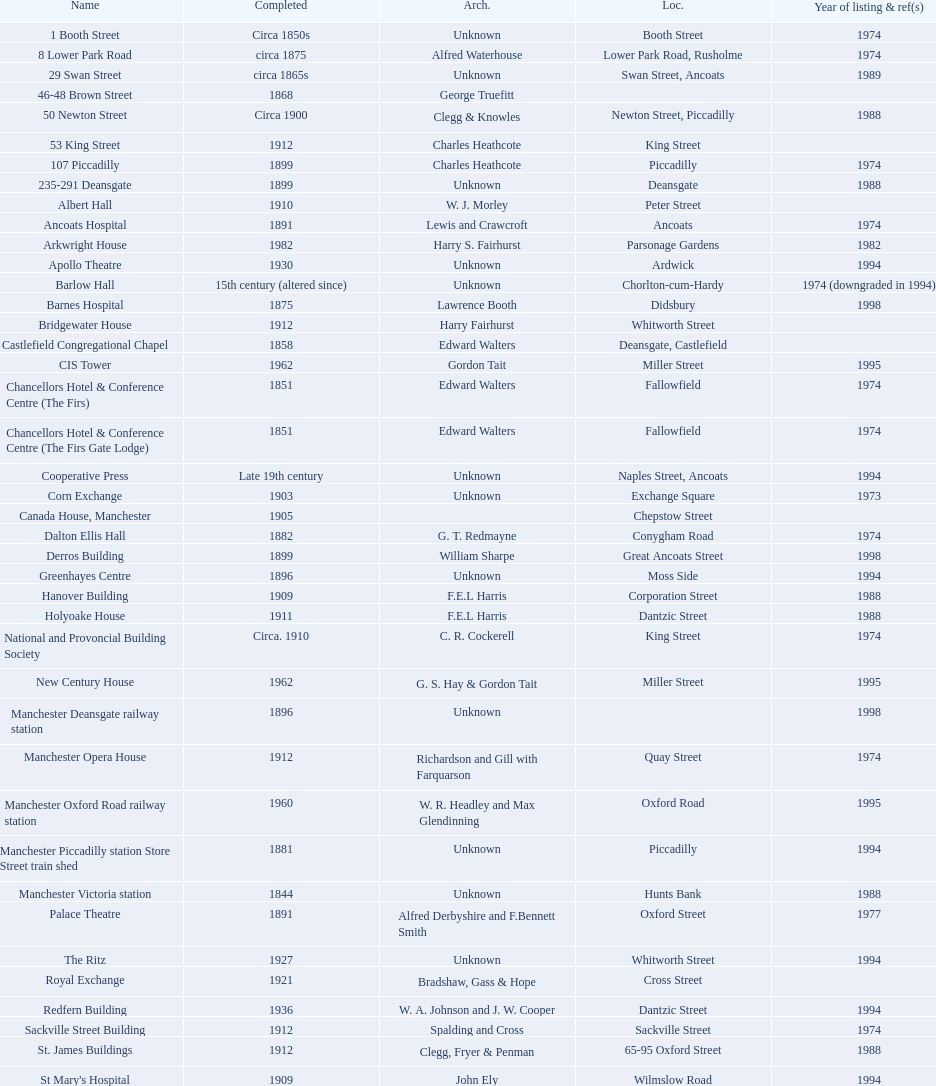How many buildings do not have an image listed? 11. 